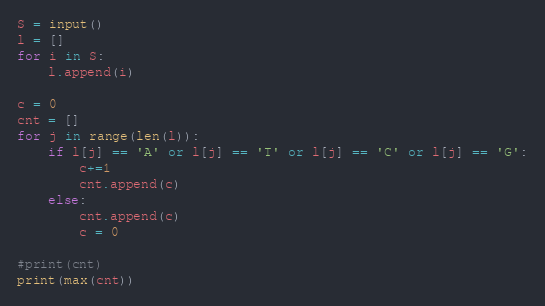Convert code to text. <code><loc_0><loc_0><loc_500><loc_500><_Python_>S = input()
l = []
for i in S:
    l.append(i)

c = 0
cnt = []
for j in range(len(l)):
    if l[j] == 'A' or l[j] == 'T' or l[j] == 'C' or l[j] == 'G':
        c+=1
        cnt.append(c)
    else:
        cnt.append(c)
        c = 0

#print(cnt)
print(max(cnt))</code> 